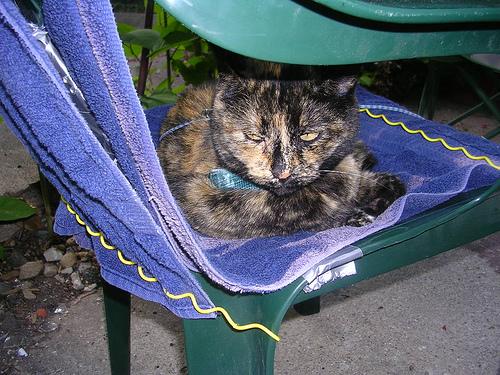What color is the towel?
Answer briefly. Blue. What is the cat sitting on?
Short answer required. Blue towel. Are the cat's eyes closed?
Write a very short answer. No. 